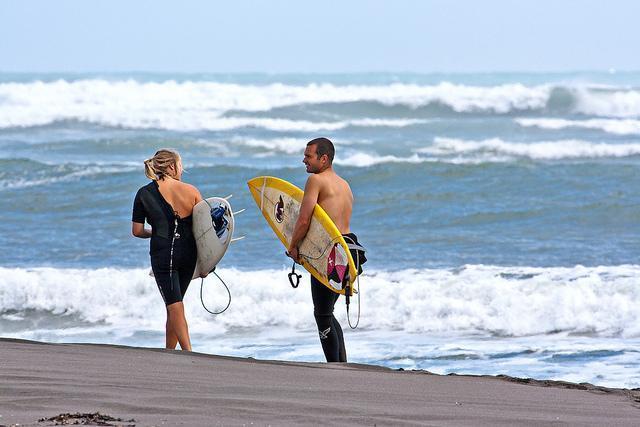How many surfboards can be seen?
Give a very brief answer. 2. How many people can you see?
Give a very brief answer. 2. 